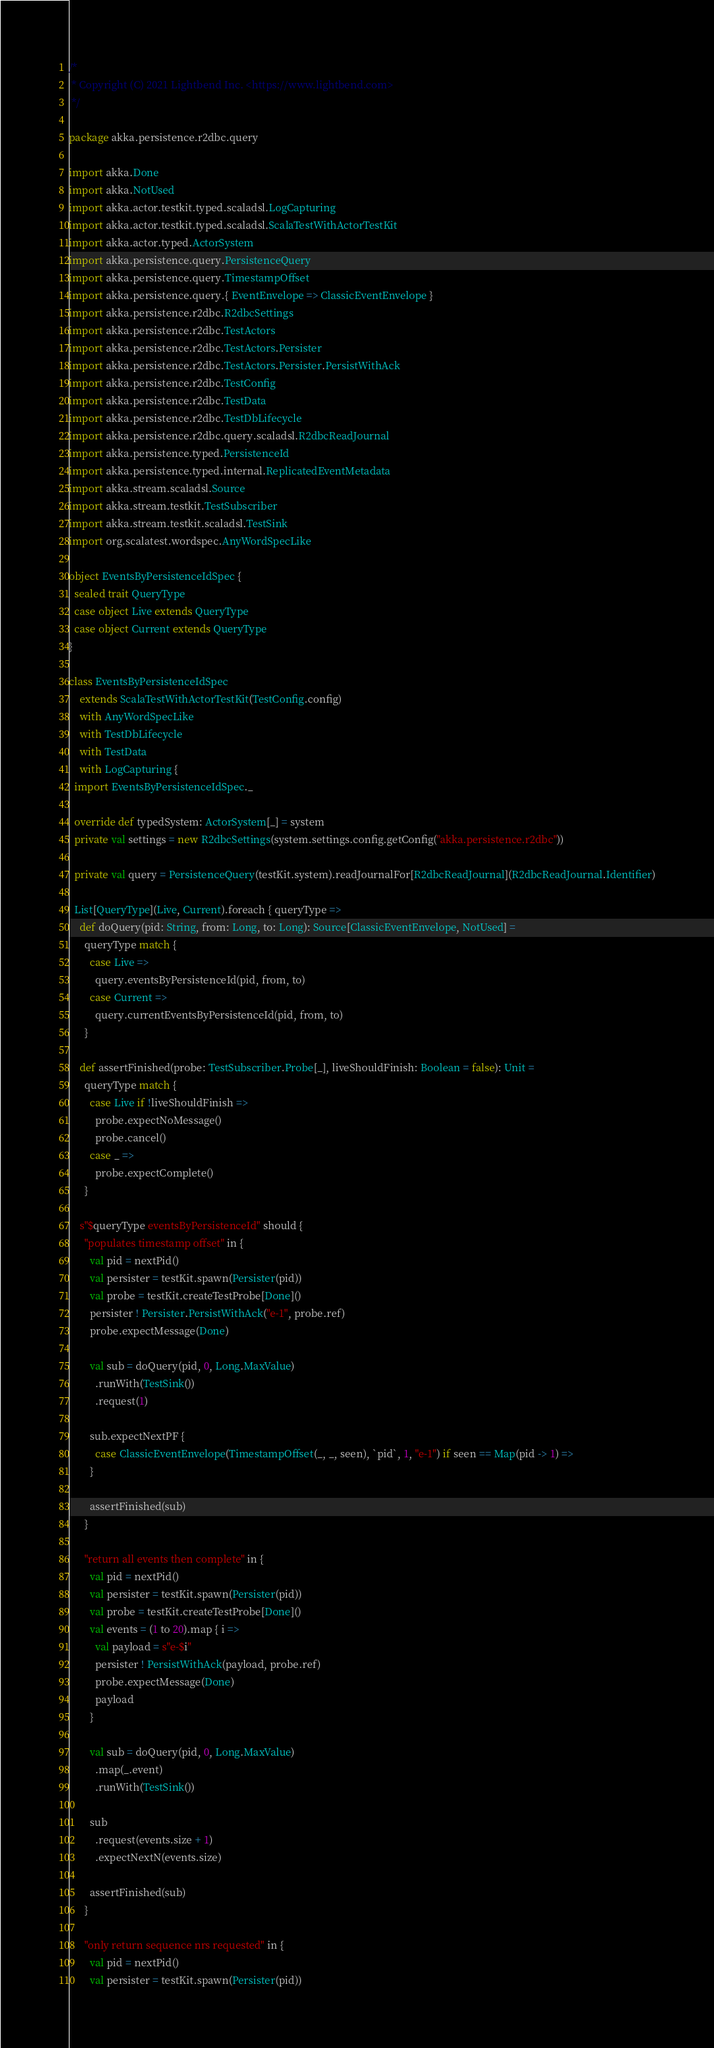Convert code to text. <code><loc_0><loc_0><loc_500><loc_500><_Scala_>/*
 * Copyright (C) 2021 Lightbend Inc. <https://www.lightbend.com>
 */

package akka.persistence.r2dbc.query

import akka.Done
import akka.NotUsed
import akka.actor.testkit.typed.scaladsl.LogCapturing
import akka.actor.testkit.typed.scaladsl.ScalaTestWithActorTestKit
import akka.actor.typed.ActorSystem
import akka.persistence.query.PersistenceQuery
import akka.persistence.query.TimestampOffset
import akka.persistence.query.{ EventEnvelope => ClassicEventEnvelope }
import akka.persistence.r2dbc.R2dbcSettings
import akka.persistence.r2dbc.TestActors
import akka.persistence.r2dbc.TestActors.Persister
import akka.persistence.r2dbc.TestActors.Persister.PersistWithAck
import akka.persistence.r2dbc.TestConfig
import akka.persistence.r2dbc.TestData
import akka.persistence.r2dbc.TestDbLifecycle
import akka.persistence.r2dbc.query.scaladsl.R2dbcReadJournal
import akka.persistence.typed.PersistenceId
import akka.persistence.typed.internal.ReplicatedEventMetadata
import akka.stream.scaladsl.Source
import akka.stream.testkit.TestSubscriber
import akka.stream.testkit.scaladsl.TestSink
import org.scalatest.wordspec.AnyWordSpecLike

object EventsByPersistenceIdSpec {
  sealed trait QueryType
  case object Live extends QueryType
  case object Current extends QueryType
}

class EventsByPersistenceIdSpec
    extends ScalaTestWithActorTestKit(TestConfig.config)
    with AnyWordSpecLike
    with TestDbLifecycle
    with TestData
    with LogCapturing {
  import EventsByPersistenceIdSpec._

  override def typedSystem: ActorSystem[_] = system
  private val settings = new R2dbcSettings(system.settings.config.getConfig("akka.persistence.r2dbc"))

  private val query = PersistenceQuery(testKit.system).readJournalFor[R2dbcReadJournal](R2dbcReadJournal.Identifier)

  List[QueryType](Live, Current).foreach { queryType =>
    def doQuery(pid: String, from: Long, to: Long): Source[ClassicEventEnvelope, NotUsed] =
      queryType match {
        case Live =>
          query.eventsByPersistenceId(pid, from, to)
        case Current =>
          query.currentEventsByPersistenceId(pid, from, to)
      }

    def assertFinished(probe: TestSubscriber.Probe[_], liveShouldFinish: Boolean = false): Unit =
      queryType match {
        case Live if !liveShouldFinish =>
          probe.expectNoMessage()
          probe.cancel()
        case _ =>
          probe.expectComplete()
      }

    s"$queryType eventsByPersistenceId" should {
      "populates timestamp offset" in {
        val pid = nextPid()
        val persister = testKit.spawn(Persister(pid))
        val probe = testKit.createTestProbe[Done]()
        persister ! Persister.PersistWithAck("e-1", probe.ref)
        probe.expectMessage(Done)

        val sub = doQuery(pid, 0, Long.MaxValue)
          .runWith(TestSink())
          .request(1)

        sub.expectNextPF {
          case ClassicEventEnvelope(TimestampOffset(_, _, seen), `pid`, 1, "e-1") if seen == Map(pid -> 1) =>
        }

        assertFinished(sub)
      }

      "return all events then complete" in {
        val pid = nextPid()
        val persister = testKit.spawn(Persister(pid))
        val probe = testKit.createTestProbe[Done]()
        val events = (1 to 20).map { i =>
          val payload = s"e-$i"
          persister ! PersistWithAck(payload, probe.ref)
          probe.expectMessage(Done)
          payload
        }

        val sub = doQuery(pid, 0, Long.MaxValue)
          .map(_.event)
          .runWith(TestSink())

        sub
          .request(events.size + 1)
          .expectNextN(events.size)

        assertFinished(sub)
      }

      "only return sequence nrs requested" in {
        val pid = nextPid()
        val persister = testKit.spawn(Persister(pid))</code> 